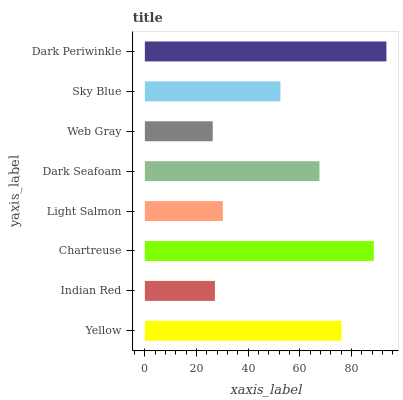Is Web Gray the minimum?
Answer yes or no. Yes. Is Dark Periwinkle the maximum?
Answer yes or no. Yes. Is Indian Red the minimum?
Answer yes or no. No. Is Indian Red the maximum?
Answer yes or no. No. Is Yellow greater than Indian Red?
Answer yes or no. Yes. Is Indian Red less than Yellow?
Answer yes or no. Yes. Is Indian Red greater than Yellow?
Answer yes or no. No. Is Yellow less than Indian Red?
Answer yes or no. No. Is Dark Seafoam the high median?
Answer yes or no. Yes. Is Sky Blue the low median?
Answer yes or no. Yes. Is Dark Periwinkle the high median?
Answer yes or no. No. Is Chartreuse the low median?
Answer yes or no. No. 